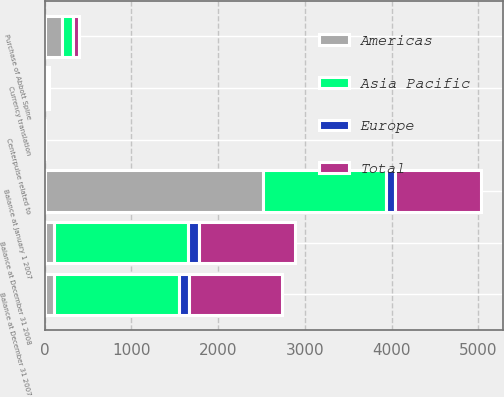Convert chart to OTSL. <chart><loc_0><loc_0><loc_500><loc_500><stacked_bar_chart><ecel><fcel>Balance at January 1 2007<fcel>Centerpulse related to<fcel>Balance at December 31 2007<fcel>Purchase of Abbott Spine<fcel>Currency translation<fcel>Balance at December 31 2008<nl><fcel>Asia Pacific<fcel>1414.1<fcel>0.1<fcel>1443.5<fcel>129.3<fcel>5.9<fcel>1540.3<nl><fcel>Total<fcel>993.9<fcel>1<fcel>1066.3<fcel>65.7<fcel>20.4<fcel>1110.1<nl><fcel>Europe<fcel>107.6<fcel>0.1<fcel>111.6<fcel>2.4<fcel>10.4<fcel>124.4<nl><fcel>Americas<fcel>2515.6<fcel>1.2<fcel>109.6<fcel>197.4<fcel>15.9<fcel>109.6<nl></chart> 